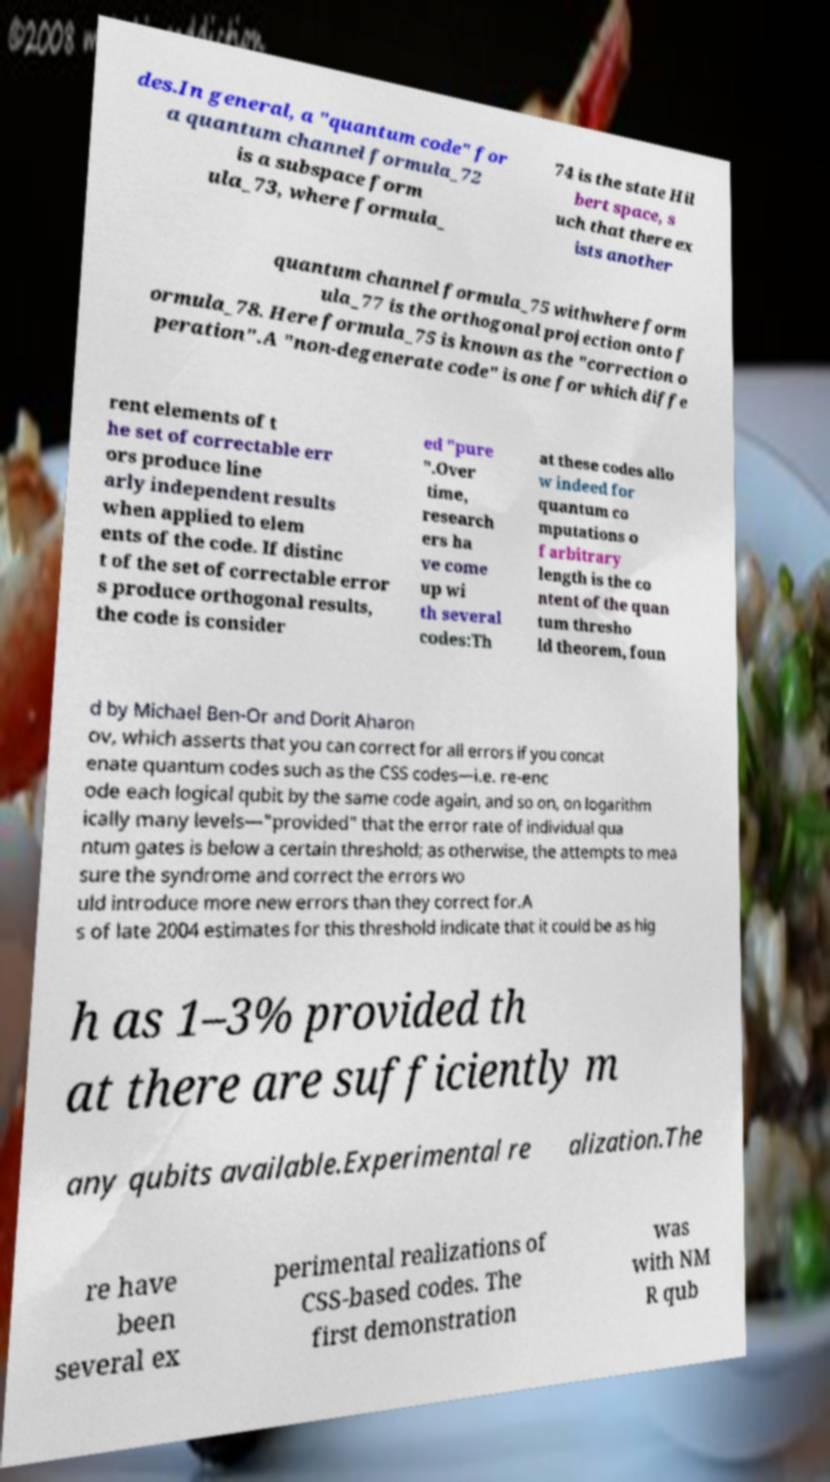For documentation purposes, I need the text within this image transcribed. Could you provide that? des.In general, a "quantum code" for a quantum channel formula_72 is a subspace form ula_73, where formula_ 74 is the state Hil bert space, s uch that there ex ists another quantum channel formula_75 withwhere form ula_77 is the orthogonal projection onto f ormula_78. Here formula_75 is known as the "correction o peration".A "non-degenerate code" is one for which diffe rent elements of t he set of correctable err ors produce line arly independent results when applied to elem ents of the code. If distinc t of the set of correctable error s produce orthogonal results, the code is consider ed "pure ".Over time, research ers ha ve come up wi th several codes:Th at these codes allo w indeed for quantum co mputations o f arbitrary length is the co ntent of the quan tum thresho ld theorem, foun d by Michael Ben-Or and Dorit Aharon ov, which asserts that you can correct for all errors if you concat enate quantum codes such as the CSS codes—i.e. re-enc ode each logical qubit by the same code again, and so on, on logarithm ically many levels—"provided" that the error rate of individual qua ntum gates is below a certain threshold; as otherwise, the attempts to mea sure the syndrome and correct the errors wo uld introduce more new errors than they correct for.A s of late 2004 estimates for this threshold indicate that it could be as hig h as 1–3% provided th at there are sufficiently m any qubits available.Experimental re alization.The re have been several ex perimental realizations of CSS-based codes. The first demonstration was with NM R qub 